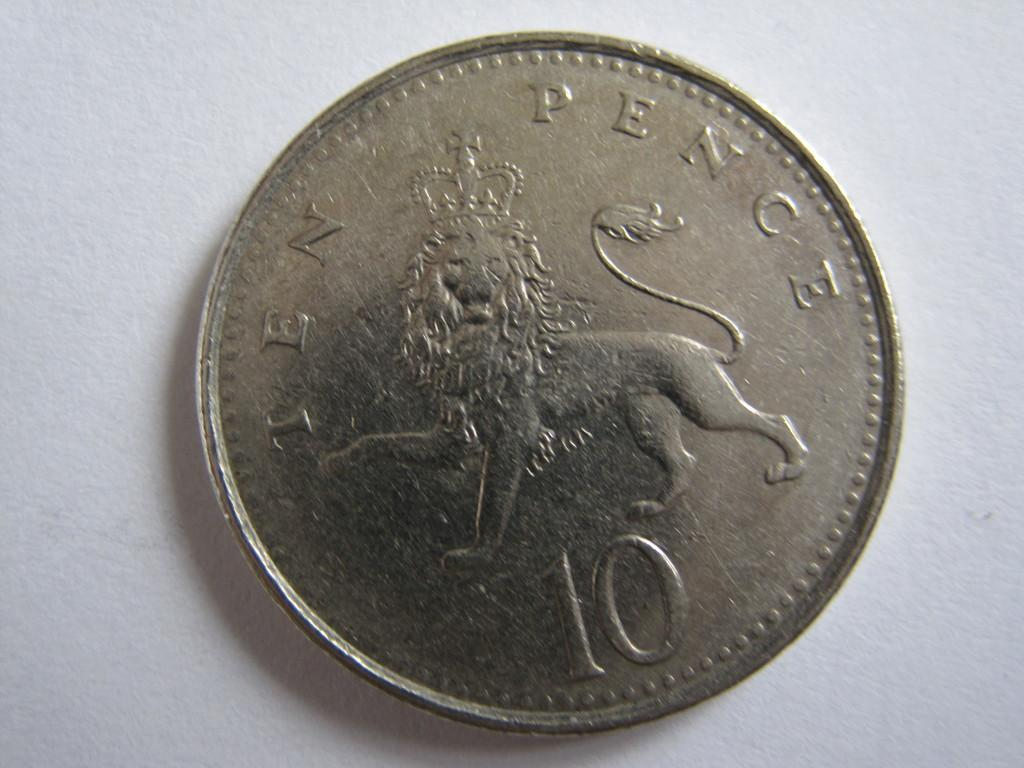<image>
Summarize the visual content of the image. A coin with a lion on it that reads ten pence with also the number 10 on it 